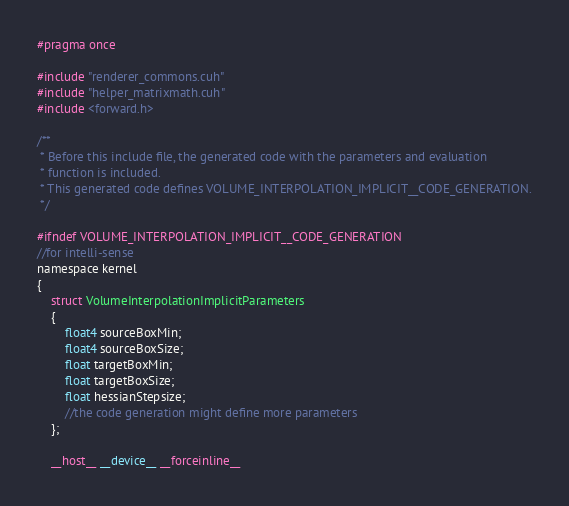<code> <loc_0><loc_0><loc_500><loc_500><_Cuda_>#pragma once

#include "renderer_commons.cuh"
#include "helper_matrixmath.cuh"
#include <forward.h>

/**
 * Before this include file, the generated code with the parameters and evaluation
 * function is included.
 * This generated code defines VOLUME_INTERPOLATION_IMPLICIT__CODE_GENERATION.
 */

#ifndef VOLUME_INTERPOLATION_IMPLICIT__CODE_GENERATION
//for intelli-sense
namespace kernel
{
    struct VolumeInterpolationImplicitParameters
    {
        float4 sourceBoxMin;
        float4 sourceBoxSize;
        float targetBoxMin;
        float targetBoxSize;
        float hessianStepsize;
        //the code generation might define more parameters
    };

    __host__ __device__ __forceinline__</code> 